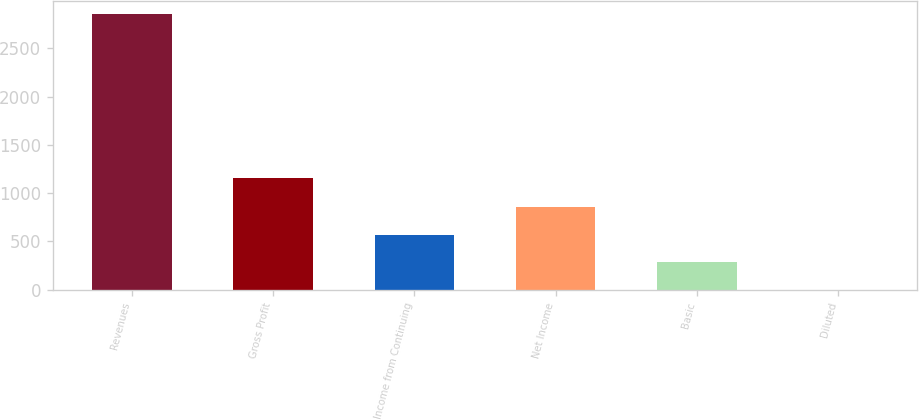Convert chart to OTSL. <chart><loc_0><loc_0><loc_500><loc_500><bar_chart><fcel>Revenues<fcel>Gross Profit<fcel>Income from Continuing<fcel>Net Income<fcel>Basic<fcel>Diluted<nl><fcel>2854<fcel>1161<fcel>571.24<fcel>856.58<fcel>285.9<fcel>0.56<nl></chart> 